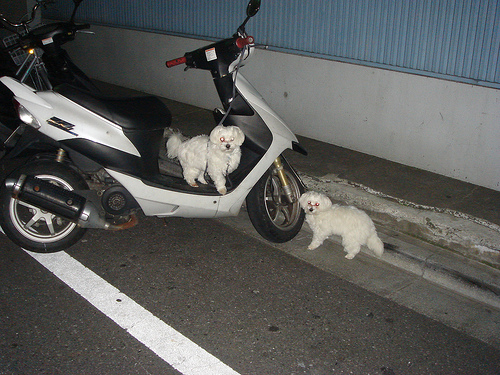Please provide the bounding box coordinate of the region this sentence describes: dog on the bike. The dog is comfortably located on the motorcycle's seat, notably positioned between [0.31, 0.29, 0.52, 0.51], where it appears to be waiting or watching. 